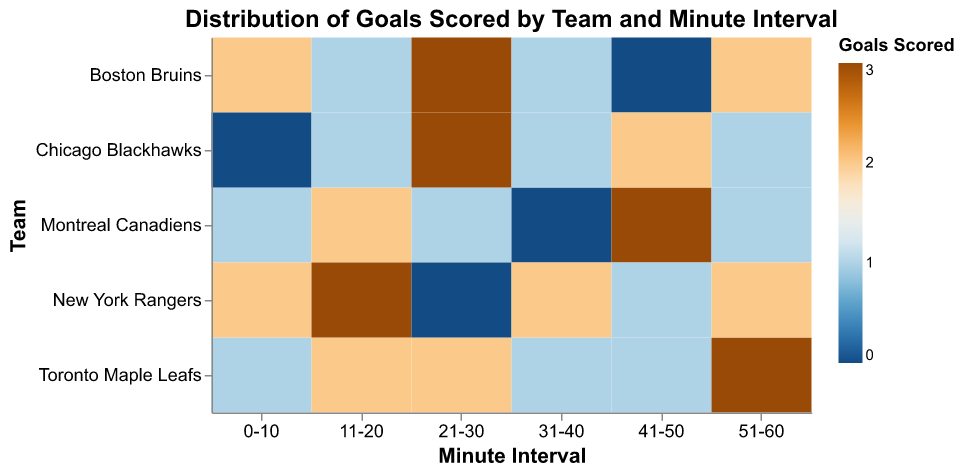What is the title of the figure? The title is usually at the top of the figure and summarizes what the figure represents. It helps to quickly understand the purpose of the figure.
Answer: Distribution of Goals Scored by Team and Minute Interval Which team scored the most goals in the 21-30 minute interval? Looking at the column "21-30 minute interval," identify which row has the highest value for goals scored.
Answer: Boston Bruins and Chicago Blackhawks How many goals did the New York Rangers score in the 41-50 minute interval? Locate the row for New York Rangers and check the value in the "41-50 minute interval" column.
Answer: 1 Which minute interval had the highest number of goals scored by all teams combined? Sum the goals scored for each minute interval across all teams and find the interval with the highest total. 
0-10: 2 + 1 + 1 + 0 + 2 = 6 
11-20: 1 + 2 + 2 + 1 + 3 = 9 
21-30: 3 + 2 + 1 + 3 + 0 = 9 
31-40: 1 + 1 + 0 + 1 + 2 = 5 
41-50: 0 + 1 + 3 + 2 + 1 = 7 
51-60: 2 + 3 + 1 + 1 + 2 = 9 
The highest value is in the intervals 11-20, 21-30, and 51-60.
Answer: 11-20, 21-30, and 51-60 Did any team have a minute interval where they scored no goals? Check each team's row, and identify if any value is 0.
Answer: Yes, Boston Bruins (41-50), Montreal Canadiens (31-40), Chicago Blackhawks (0-10), New York Rangers (21-30) What is the average number of goals scored by the Toronto Maple Leafs across all intervals? Sum the goals scored by the Toronto Maple Leafs across all intervals and divide by the number of intervals (6). 
1 + 2 + 2 + 1 + 1 + 3 = 10 
Average = 10/6 ≈ 1.67
Answer: 1.67 Which team scored the highest number of goals in the 51-60 minute interval? Compare the values in the "51-60 minute interval" column and identify the highest value.
Answer: Toronto Maple Leafs Does the Boston Bruins have a higher total number of goals scored than the Chicago Blackhawks? Calculate the total goals scored by both teams and compare.
Boston Bruins: 2 + 1 + 3 + 1 + 0 + 2 = 9 
Chicago Blackhawks: 0 + 1 + 3 + 1 + 2 + 1 = 8 
Boston Bruins scored more.
Answer: Yes In which minute interval did the Montreal Canadiens score their maximum goals? Look at the Montreal Canadiens row and identify the column with the highest value.
Answer: 41-50 